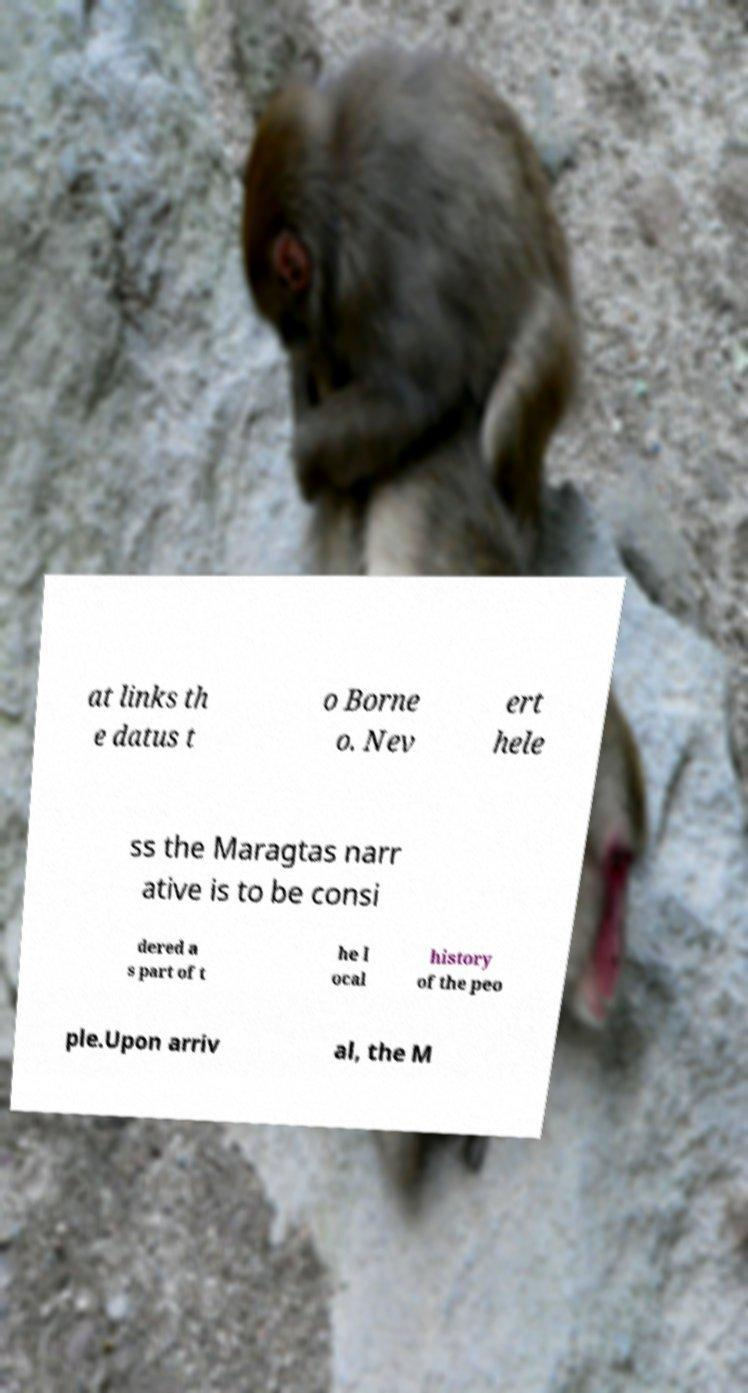I need the written content from this picture converted into text. Can you do that? at links th e datus t o Borne o. Nev ert hele ss the Maragtas narr ative is to be consi dered a s part of t he l ocal history of the peo ple.Upon arriv al, the M 